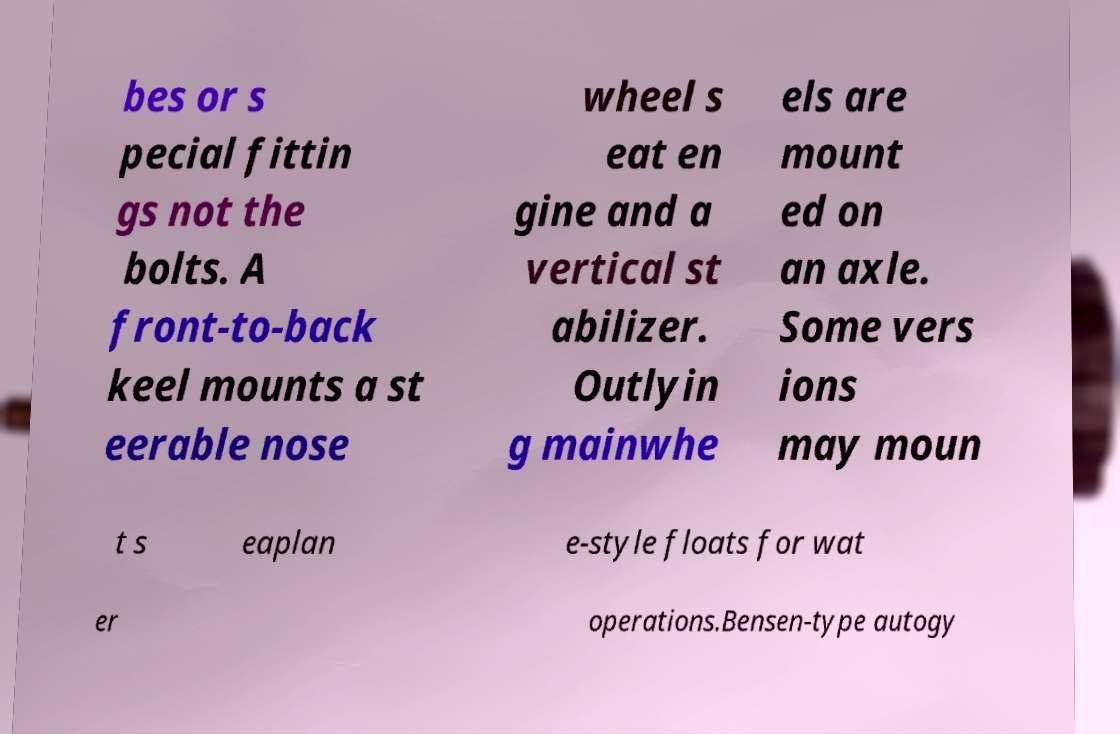Could you extract and type out the text from this image? bes or s pecial fittin gs not the bolts. A front-to-back keel mounts a st eerable nose wheel s eat en gine and a vertical st abilizer. Outlyin g mainwhe els are mount ed on an axle. Some vers ions may moun t s eaplan e-style floats for wat er operations.Bensen-type autogy 